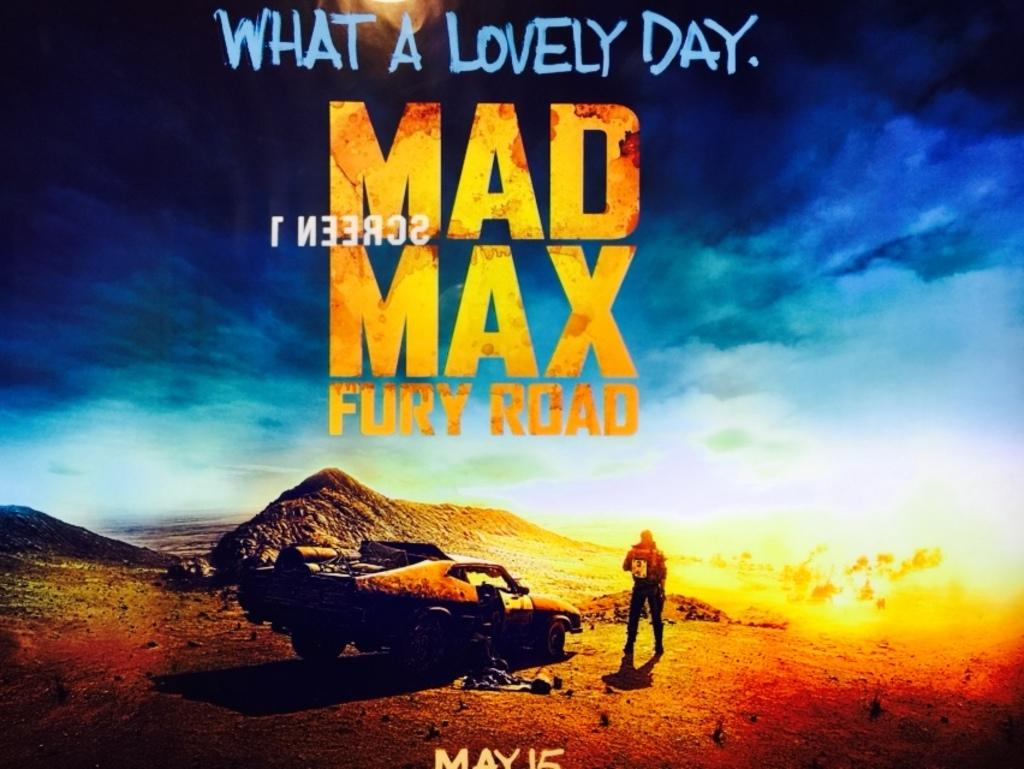Provide a one-sentence caption for the provided image. A movie poster for Mad Max Fury Road, which reads "What a Lovely Day." at the top of the poster and "May 15" on the bottom. 